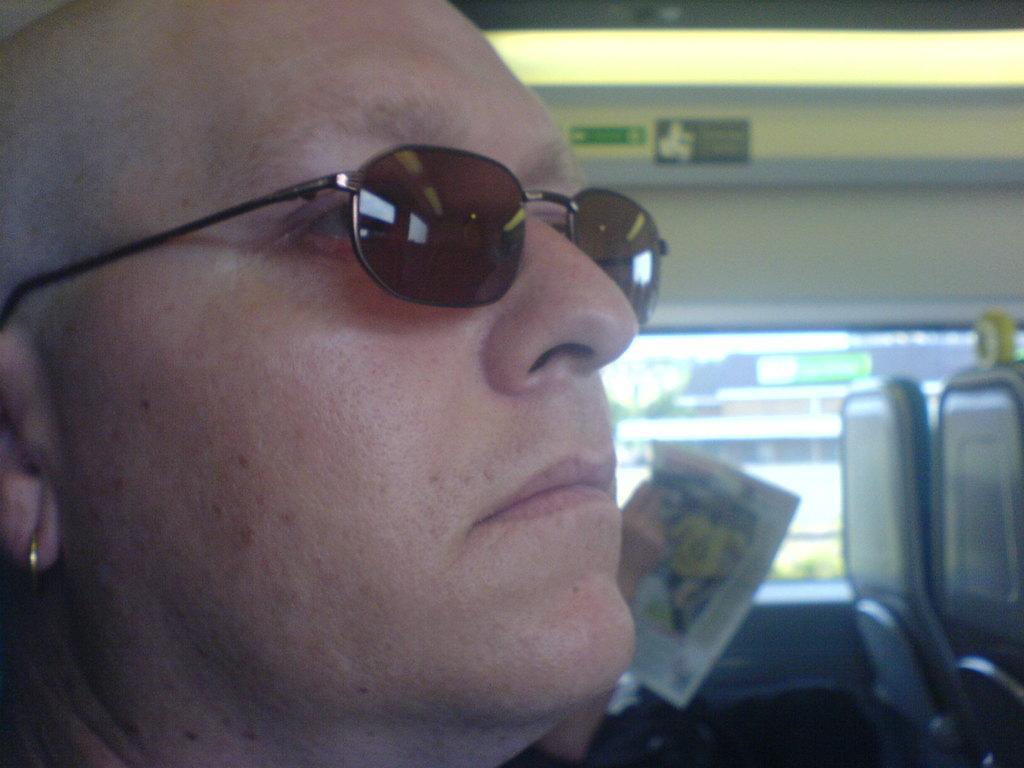Please provide a concise description of this image. This image is taken in a vehicle. On the left side of the image there is a man. On the right side of the image there are two seats and a person is sitting on the seat and holding a newspaper in the hands. In the background there is a window. 